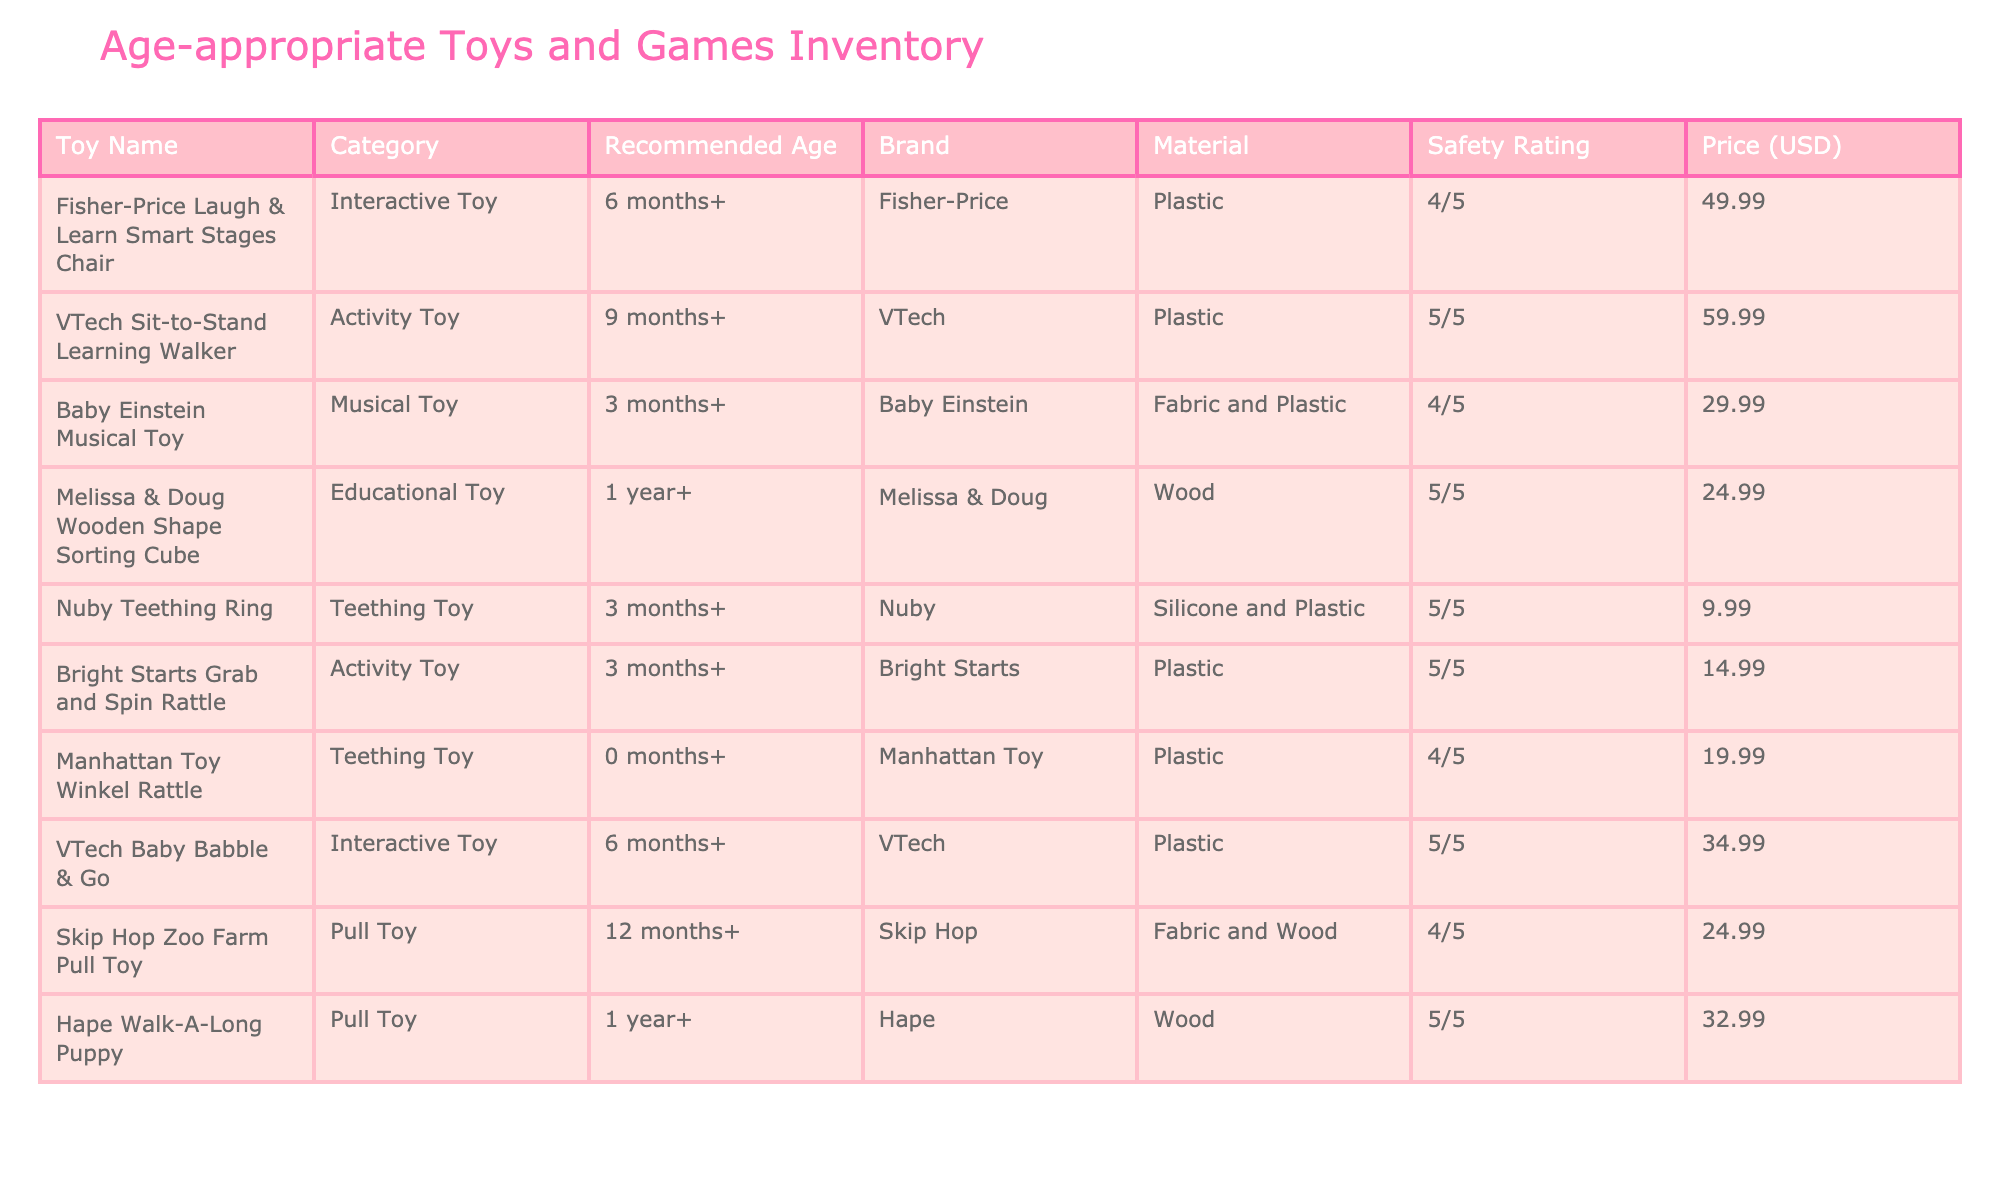What is the price of the Fisher-Price Laugh & Learn Smart Stages Chair? The table lists the price of the Fisher-Price Laugh & Learn Smart Stages Chair under the 'Price (USD)' column, which shows $49.99.
Answer: $49.99 Which toy has the highest safety rating? The table indicates safety ratings for each toy; the VTech Sit-to-Stand Learning Walker, along with the Nuby Teething Ring, and the Hape Walk-A-Long Puppy, all have a safety rating of 5/5, which is the highest rating.
Answer: VTech Sit-to-Stand Learning Walker, Nuby Teething Ring, Hape Walk-A-Long Puppy Is the Baby Einstein Musical Toy suitable for a newborn? The Baby Einstein Musical Toy has a recommended age of 3 months and older, meaning it is not suitable for a newborn (0 months).
Answer: No What is the total price of the teething toys listed? The teething toys are the Nuby Teething Ring at $9.99 and the Manhattan Toy Winkel Rattle at $19.99. Adding these gives us $9.99 + $19.99 = $29.98 as the total price for teething toys.
Answer: $29.98 How many toys are recommended for children ages 1 year and up? The table shows three toys that are recommended for ages 1 year and up: the Melissa & Doug Wooden Shape Sorting Cube, the Hape Walk-A-Long Puppy, and the Skip Hop Zoo Farm Pull Toy. Thus, there are 3 toys listed for this age group.
Answer: 3 What is the average price of all the interactive toys? The interactive toys listed are the Fisher-Price Laugh & Learn Smart Stages Chair ($49.99) and the VTech Baby Babble & Go ($34.99). Adding these prices gives us $49.99 + $34.99 = $84.98. Dividing by 2 (the number of interactive toys) gives us an average of $42.49.
Answer: $42.49 Does the inventory include any fabric toys? The table lists two fabric toys: the Bright Starts Grab and Spin Rattle (Activity Toy) and the Skip Hop Zoo Farm Pull Toy. Therefore, the inventory does include fabric toys.
Answer: Yes Which toy has the lowest price? The table indicates that the Nuby Teething Ring is priced at $9.99, which is the lowest price among all the toys listed in the inventory.
Answer: $9.99 How many toys are suitable for a child that is 1 year old according to this inventory? The toys suitable for 1-year-olds include the Melissa & Doug Wooden Shape Sorting Cube, the Hape Walk-A-Long Puppy, and the Skip Hop Zoo Farm Pull Toy, totaling three toys suitable for a 1-year-old.
Answer: 3 